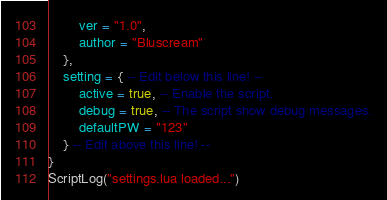Convert code to text. <code><loc_0><loc_0><loc_500><loc_500><_Lua_>		ver = "1.0",
		author = "Bluscream"
	},
	setting = { -- Edit below this line! --
		active = true, -- Enable the script.
		debug = true, -- The script show debug messages.
		defaultPW = "123"
	} -- Edit above this line! --
}
ScriptLog("settings.lua loaded...")
</code> 